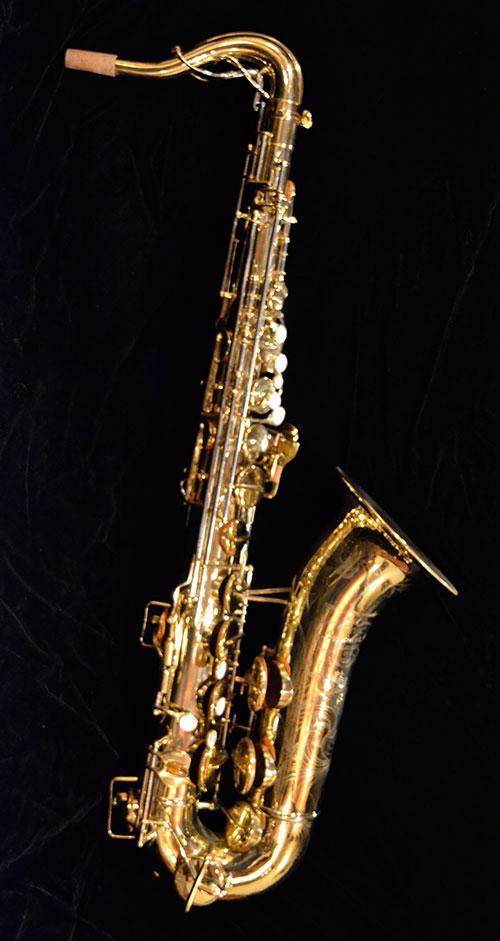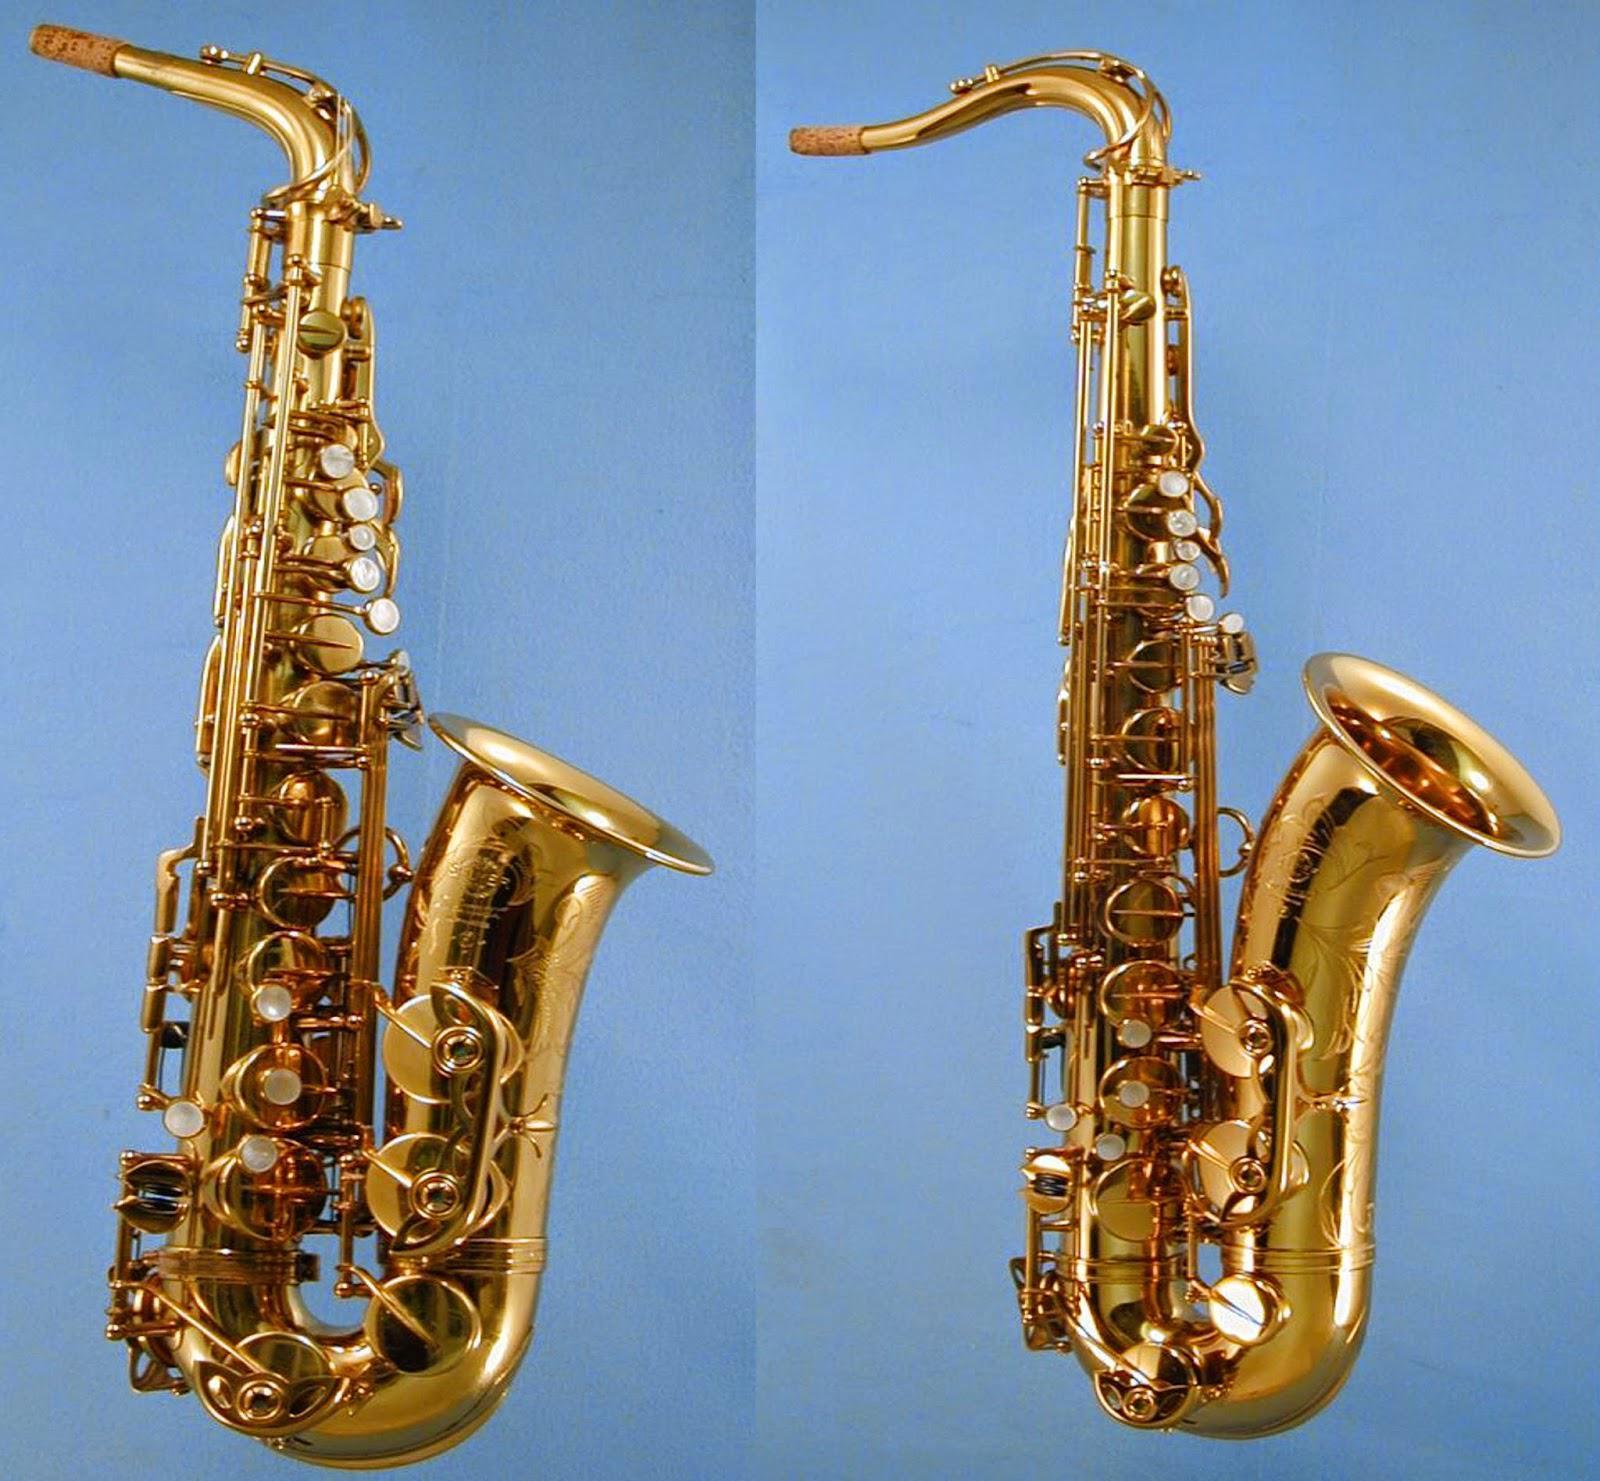The first image is the image on the left, the second image is the image on the right. For the images shown, is this caption "There is a single sax in one of the images, and two in the other." true? Answer yes or no. Yes. The first image is the image on the left, the second image is the image on the right. Considering the images on both sides, is "Each saxophone is displayed with its bell facing rightward and its mouthpiece attached, but no saxophone is held by a person." valid? Answer yes or no. Yes. 